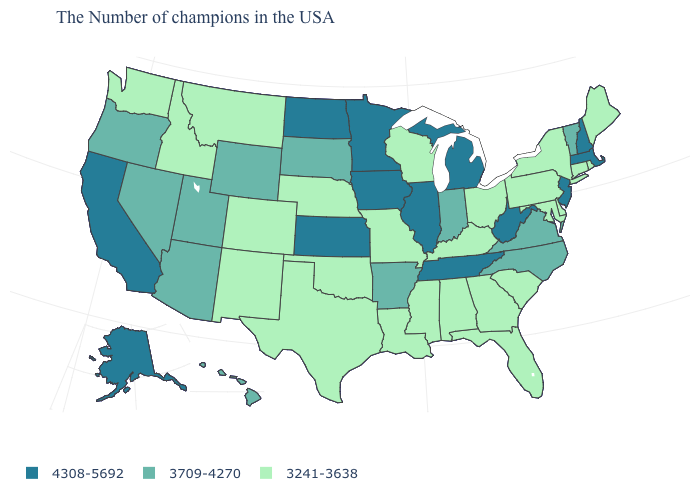Which states have the highest value in the USA?
Be succinct. Massachusetts, New Hampshire, New Jersey, West Virginia, Michigan, Tennessee, Illinois, Minnesota, Iowa, Kansas, North Dakota, California, Alaska. Among the states that border Connecticut , which have the lowest value?
Answer briefly. Rhode Island, New York. What is the value of North Dakota?
Keep it brief. 4308-5692. What is the value of Delaware?
Be succinct. 3241-3638. What is the value of Idaho?
Short answer required. 3241-3638. What is the value of Ohio?
Quick response, please. 3241-3638. Which states hav the highest value in the South?
Quick response, please. West Virginia, Tennessee. Does Utah have the lowest value in the USA?
Short answer required. No. What is the value of Missouri?
Quick response, please. 3241-3638. What is the value of Rhode Island?
Keep it brief. 3241-3638. Name the states that have a value in the range 3241-3638?
Keep it brief. Maine, Rhode Island, Connecticut, New York, Delaware, Maryland, Pennsylvania, South Carolina, Ohio, Florida, Georgia, Kentucky, Alabama, Wisconsin, Mississippi, Louisiana, Missouri, Nebraska, Oklahoma, Texas, Colorado, New Mexico, Montana, Idaho, Washington. Which states have the highest value in the USA?
Quick response, please. Massachusetts, New Hampshire, New Jersey, West Virginia, Michigan, Tennessee, Illinois, Minnesota, Iowa, Kansas, North Dakota, California, Alaska. What is the highest value in states that border Washington?
Write a very short answer. 3709-4270. How many symbols are there in the legend?
Write a very short answer. 3. Does Arizona have the highest value in the USA?
Keep it brief. No. 